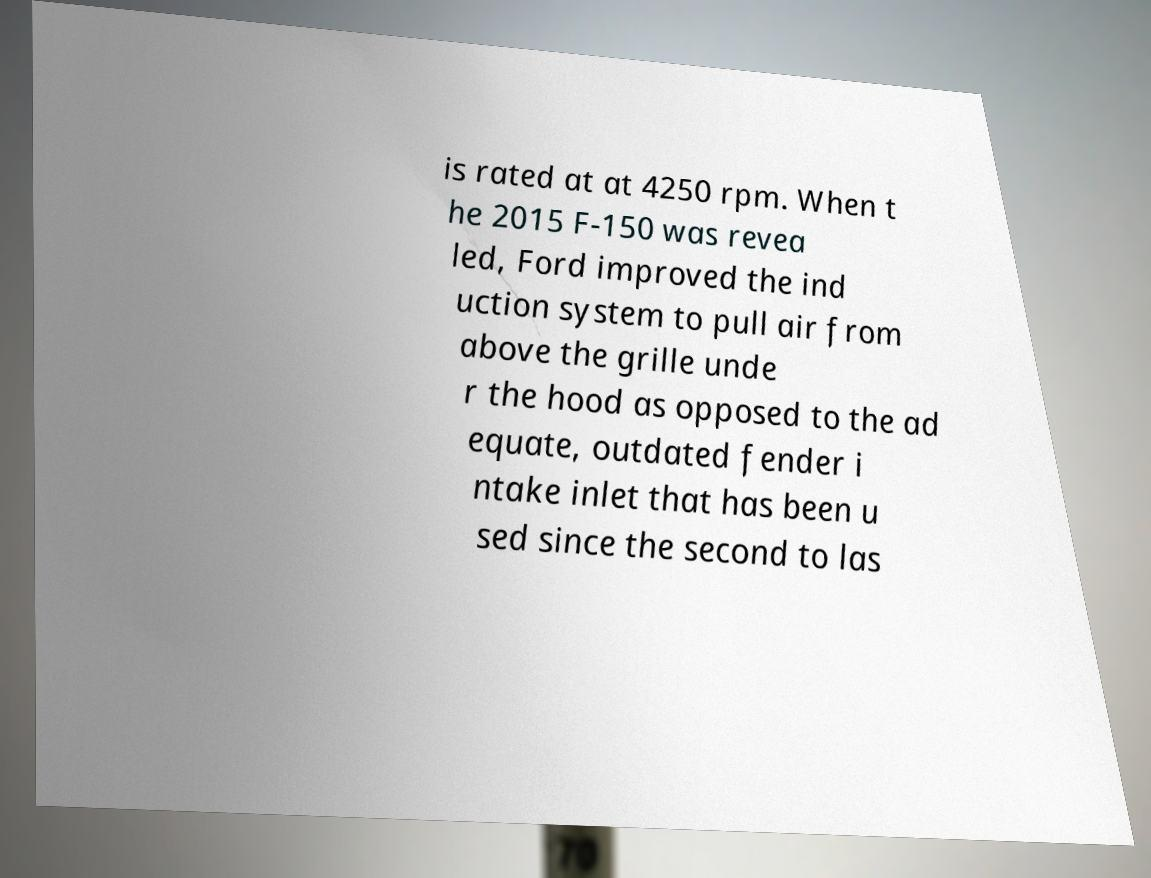What messages or text are displayed in this image? I need them in a readable, typed format. is rated at at 4250 rpm. When t he 2015 F-150 was revea led, Ford improved the ind uction system to pull air from above the grille unde r the hood as opposed to the ad equate, outdated fender i ntake inlet that has been u sed since the second to las 